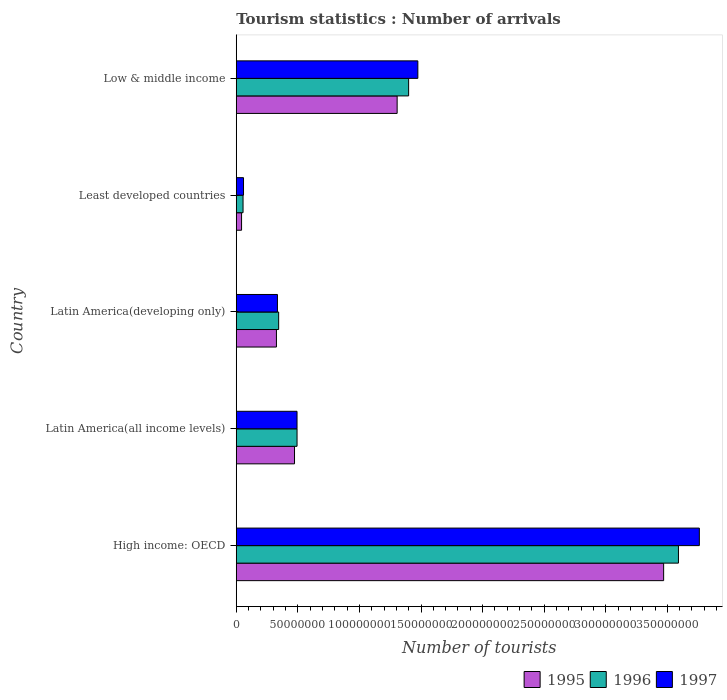How many groups of bars are there?
Offer a very short reply. 5. How many bars are there on the 2nd tick from the bottom?
Your response must be concise. 3. What is the label of the 3rd group of bars from the top?
Offer a terse response. Latin America(developing only). What is the number of tourist arrivals in 1997 in Latin America(all income levels)?
Offer a very short reply. 4.93e+07. Across all countries, what is the maximum number of tourist arrivals in 1995?
Your response must be concise. 3.47e+08. Across all countries, what is the minimum number of tourist arrivals in 1995?
Ensure brevity in your answer.  4.31e+06. In which country was the number of tourist arrivals in 1995 maximum?
Offer a very short reply. High income: OECD. In which country was the number of tourist arrivals in 1995 minimum?
Give a very brief answer. Least developed countries. What is the total number of tourist arrivals in 1996 in the graph?
Keep it short and to the point. 5.88e+08. What is the difference between the number of tourist arrivals in 1996 in Latin America(all income levels) and that in Latin America(developing only)?
Make the answer very short. 1.49e+07. What is the difference between the number of tourist arrivals in 1995 in High income: OECD and the number of tourist arrivals in 1997 in Latin America(all income levels)?
Keep it short and to the point. 2.98e+08. What is the average number of tourist arrivals in 1996 per country?
Provide a short and direct response. 1.18e+08. What is the difference between the number of tourist arrivals in 1997 and number of tourist arrivals in 1996 in High income: OECD?
Offer a very short reply. 1.70e+07. What is the ratio of the number of tourist arrivals in 1996 in Latin America(developing only) to that in Least developed countries?
Provide a short and direct response. 6.24. Is the difference between the number of tourist arrivals in 1997 in High income: OECD and Low & middle income greater than the difference between the number of tourist arrivals in 1996 in High income: OECD and Low & middle income?
Keep it short and to the point. Yes. What is the difference between the highest and the second highest number of tourist arrivals in 1997?
Offer a terse response. 2.29e+08. What is the difference between the highest and the lowest number of tourist arrivals in 1996?
Offer a terse response. 3.54e+08. Is it the case that in every country, the sum of the number of tourist arrivals in 1997 and number of tourist arrivals in 1996 is greater than the number of tourist arrivals in 1995?
Give a very brief answer. Yes. How many bars are there?
Give a very brief answer. 15. Are the values on the major ticks of X-axis written in scientific E-notation?
Offer a terse response. No. Where does the legend appear in the graph?
Your answer should be compact. Bottom right. How many legend labels are there?
Make the answer very short. 3. What is the title of the graph?
Provide a succinct answer. Tourism statistics : Number of arrivals. What is the label or title of the X-axis?
Your answer should be compact. Number of tourists. What is the Number of tourists of 1995 in High income: OECD?
Give a very brief answer. 3.47e+08. What is the Number of tourists in 1996 in High income: OECD?
Offer a very short reply. 3.59e+08. What is the Number of tourists in 1997 in High income: OECD?
Your answer should be very brief. 3.76e+08. What is the Number of tourists of 1995 in Latin America(all income levels)?
Offer a terse response. 4.73e+07. What is the Number of tourists in 1996 in Latin America(all income levels)?
Make the answer very short. 4.94e+07. What is the Number of tourists in 1997 in Latin America(all income levels)?
Offer a terse response. 4.93e+07. What is the Number of tourists of 1995 in Latin America(developing only)?
Provide a succinct answer. 3.26e+07. What is the Number of tourists of 1996 in Latin America(developing only)?
Give a very brief answer. 3.44e+07. What is the Number of tourists in 1997 in Latin America(developing only)?
Offer a very short reply. 3.34e+07. What is the Number of tourists in 1995 in Least developed countries?
Your response must be concise. 4.31e+06. What is the Number of tourists in 1996 in Least developed countries?
Your answer should be compact. 5.52e+06. What is the Number of tourists of 1997 in Least developed countries?
Your answer should be very brief. 5.89e+06. What is the Number of tourists in 1995 in Low & middle income?
Offer a terse response. 1.31e+08. What is the Number of tourists of 1996 in Low & middle income?
Your answer should be very brief. 1.40e+08. What is the Number of tourists in 1997 in Low & middle income?
Your response must be concise. 1.47e+08. Across all countries, what is the maximum Number of tourists in 1995?
Make the answer very short. 3.47e+08. Across all countries, what is the maximum Number of tourists in 1996?
Your answer should be very brief. 3.59e+08. Across all countries, what is the maximum Number of tourists of 1997?
Your response must be concise. 3.76e+08. Across all countries, what is the minimum Number of tourists in 1995?
Provide a succinct answer. 4.31e+06. Across all countries, what is the minimum Number of tourists of 1996?
Your answer should be very brief. 5.52e+06. Across all countries, what is the minimum Number of tourists of 1997?
Keep it short and to the point. 5.89e+06. What is the total Number of tourists of 1995 in the graph?
Your response must be concise. 5.62e+08. What is the total Number of tourists of 1996 in the graph?
Ensure brevity in your answer.  5.88e+08. What is the total Number of tourists of 1997 in the graph?
Offer a very short reply. 6.12e+08. What is the difference between the Number of tourists of 1995 in High income: OECD and that in Latin America(all income levels)?
Provide a succinct answer. 3.00e+08. What is the difference between the Number of tourists in 1996 in High income: OECD and that in Latin America(all income levels)?
Give a very brief answer. 3.10e+08. What is the difference between the Number of tourists of 1997 in High income: OECD and that in Latin America(all income levels)?
Keep it short and to the point. 3.27e+08. What is the difference between the Number of tourists of 1995 in High income: OECD and that in Latin America(developing only)?
Offer a very short reply. 3.14e+08. What is the difference between the Number of tourists in 1996 in High income: OECD and that in Latin America(developing only)?
Ensure brevity in your answer.  3.25e+08. What is the difference between the Number of tourists of 1997 in High income: OECD and that in Latin America(developing only)?
Keep it short and to the point. 3.43e+08. What is the difference between the Number of tourists in 1995 in High income: OECD and that in Least developed countries?
Give a very brief answer. 3.43e+08. What is the difference between the Number of tourists of 1996 in High income: OECD and that in Least developed countries?
Your response must be concise. 3.54e+08. What is the difference between the Number of tourists of 1997 in High income: OECD and that in Least developed countries?
Give a very brief answer. 3.70e+08. What is the difference between the Number of tourists in 1995 in High income: OECD and that in Low & middle income?
Make the answer very short. 2.16e+08. What is the difference between the Number of tourists of 1996 in High income: OECD and that in Low & middle income?
Provide a short and direct response. 2.19e+08. What is the difference between the Number of tourists of 1997 in High income: OECD and that in Low & middle income?
Ensure brevity in your answer.  2.29e+08. What is the difference between the Number of tourists of 1995 in Latin America(all income levels) and that in Latin America(developing only)?
Make the answer very short. 1.47e+07. What is the difference between the Number of tourists of 1996 in Latin America(all income levels) and that in Latin America(developing only)?
Give a very brief answer. 1.49e+07. What is the difference between the Number of tourists of 1997 in Latin America(all income levels) and that in Latin America(developing only)?
Your answer should be very brief. 1.59e+07. What is the difference between the Number of tourists of 1995 in Latin America(all income levels) and that in Least developed countries?
Your answer should be compact. 4.30e+07. What is the difference between the Number of tourists of 1996 in Latin America(all income levels) and that in Least developed countries?
Your answer should be compact. 4.38e+07. What is the difference between the Number of tourists of 1997 in Latin America(all income levels) and that in Least developed countries?
Provide a short and direct response. 4.34e+07. What is the difference between the Number of tourists in 1995 in Latin America(all income levels) and that in Low & middle income?
Ensure brevity in your answer.  -8.33e+07. What is the difference between the Number of tourists in 1996 in Latin America(all income levels) and that in Low & middle income?
Provide a succinct answer. -9.06e+07. What is the difference between the Number of tourists of 1997 in Latin America(all income levels) and that in Low & middle income?
Offer a very short reply. -9.81e+07. What is the difference between the Number of tourists in 1995 in Latin America(developing only) and that in Least developed countries?
Offer a terse response. 2.83e+07. What is the difference between the Number of tourists of 1996 in Latin America(developing only) and that in Least developed countries?
Provide a short and direct response. 2.89e+07. What is the difference between the Number of tourists in 1997 in Latin America(developing only) and that in Least developed countries?
Offer a very short reply. 2.76e+07. What is the difference between the Number of tourists in 1995 in Latin America(developing only) and that in Low & middle income?
Your answer should be compact. -9.80e+07. What is the difference between the Number of tourists of 1996 in Latin America(developing only) and that in Low & middle income?
Keep it short and to the point. -1.06e+08. What is the difference between the Number of tourists in 1997 in Latin America(developing only) and that in Low & middle income?
Your answer should be compact. -1.14e+08. What is the difference between the Number of tourists in 1995 in Least developed countries and that in Low & middle income?
Your answer should be very brief. -1.26e+08. What is the difference between the Number of tourists in 1996 in Least developed countries and that in Low & middle income?
Your answer should be very brief. -1.34e+08. What is the difference between the Number of tourists of 1997 in Least developed countries and that in Low & middle income?
Provide a short and direct response. -1.42e+08. What is the difference between the Number of tourists in 1995 in High income: OECD and the Number of tourists in 1996 in Latin America(all income levels)?
Offer a very short reply. 2.98e+08. What is the difference between the Number of tourists of 1995 in High income: OECD and the Number of tourists of 1997 in Latin America(all income levels)?
Provide a succinct answer. 2.98e+08. What is the difference between the Number of tourists of 1996 in High income: OECD and the Number of tourists of 1997 in Latin America(all income levels)?
Make the answer very short. 3.10e+08. What is the difference between the Number of tourists in 1995 in High income: OECD and the Number of tourists in 1996 in Latin America(developing only)?
Make the answer very short. 3.13e+08. What is the difference between the Number of tourists of 1995 in High income: OECD and the Number of tourists of 1997 in Latin America(developing only)?
Give a very brief answer. 3.14e+08. What is the difference between the Number of tourists in 1996 in High income: OECD and the Number of tourists in 1997 in Latin America(developing only)?
Your response must be concise. 3.26e+08. What is the difference between the Number of tourists of 1995 in High income: OECD and the Number of tourists of 1996 in Least developed countries?
Your answer should be very brief. 3.41e+08. What is the difference between the Number of tourists in 1995 in High income: OECD and the Number of tourists in 1997 in Least developed countries?
Make the answer very short. 3.41e+08. What is the difference between the Number of tourists of 1996 in High income: OECD and the Number of tourists of 1997 in Least developed countries?
Offer a very short reply. 3.53e+08. What is the difference between the Number of tourists in 1995 in High income: OECD and the Number of tourists in 1996 in Low & middle income?
Provide a short and direct response. 2.07e+08. What is the difference between the Number of tourists in 1995 in High income: OECD and the Number of tourists in 1997 in Low & middle income?
Give a very brief answer. 2.00e+08. What is the difference between the Number of tourists of 1996 in High income: OECD and the Number of tourists of 1997 in Low & middle income?
Your answer should be compact. 2.12e+08. What is the difference between the Number of tourists of 1995 in Latin America(all income levels) and the Number of tourists of 1996 in Latin America(developing only)?
Provide a succinct answer. 1.29e+07. What is the difference between the Number of tourists in 1995 in Latin America(all income levels) and the Number of tourists in 1997 in Latin America(developing only)?
Ensure brevity in your answer.  1.39e+07. What is the difference between the Number of tourists in 1996 in Latin America(all income levels) and the Number of tourists in 1997 in Latin America(developing only)?
Offer a terse response. 1.59e+07. What is the difference between the Number of tourists in 1995 in Latin America(all income levels) and the Number of tourists in 1996 in Least developed countries?
Provide a short and direct response. 4.18e+07. What is the difference between the Number of tourists in 1995 in Latin America(all income levels) and the Number of tourists in 1997 in Least developed countries?
Keep it short and to the point. 4.14e+07. What is the difference between the Number of tourists of 1996 in Latin America(all income levels) and the Number of tourists of 1997 in Least developed countries?
Give a very brief answer. 4.35e+07. What is the difference between the Number of tourists in 1995 in Latin America(all income levels) and the Number of tourists in 1996 in Low & middle income?
Your answer should be compact. -9.27e+07. What is the difference between the Number of tourists of 1995 in Latin America(all income levels) and the Number of tourists of 1997 in Low & middle income?
Your answer should be very brief. -1.00e+08. What is the difference between the Number of tourists in 1996 in Latin America(all income levels) and the Number of tourists in 1997 in Low & middle income?
Your answer should be very brief. -9.81e+07. What is the difference between the Number of tourists of 1995 in Latin America(developing only) and the Number of tourists of 1996 in Least developed countries?
Offer a terse response. 2.71e+07. What is the difference between the Number of tourists of 1995 in Latin America(developing only) and the Number of tourists of 1997 in Least developed countries?
Make the answer very short. 2.67e+07. What is the difference between the Number of tourists of 1996 in Latin America(developing only) and the Number of tourists of 1997 in Least developed countries?
Provide a succinct answer. 2.85e+07. What is the difference between the Number of tourists in 1995 in Latin America(developing only) and the Number of tourists in 1996 in Low & middle income?
Offer a very short reply. -1.07e+08. What is the difference between the Number of tourists in 1995 in Latin America(developing only) and the Number of tourists in 1997 in Low & middle income?
Provide a short and direct response. -1.15e+08. What is the difference between the Number of tourists of 1996 in Latin America(developing only) and the Number of tourists of 1997 in Low & middle income?
Provide a short and direct response. -1.13e+08. What is the difference between the Number of tourists of 1995 in Least developed countries and the Number of tourists of 1996 in Low & middle income?
Ensure brevity in your answer.  -1.36e+08. What is the difference between the Number of tourists of 1995 in Least developed countries and the Number of tourists of 1997 in Low & middle income?
Offer a very short reply. -1.43e+08. What is the difference between the Number of tourists of 1996 in Least developed countries and the Number of tourists of 1997 in Low & middle income?
Make the answer very short. -1.42e+08. What is the average Number of tourists of 1995 per country?
Make the answer very short. 1.12e+08. What is the average Number of tourists of 1996 per country?
Give a very brief answer. 1.18e+08. What is the average Number of tourists in 1997 per country?
Keep it short and to the point. 1.22e+08. What is the difference between the Number of tourists of 1995 and Number of tourists of 1996 in High income: OECD?
Keep it short and to the point. -1.20e+07. What is the difference between the Number of tourists of 1995 and Number of tourists of 1997 in High income: OECD?
Ensure brevity in your answer.  -2.90e+07. What is the difference between the Number of tourists of 1996 and Number of tourists of 1997 in High income: OECD?
Offer a terse response. -1.70e+07. What is the difference between the Number of tourists in 1995 and Number of tourists in 1996 in Latin America(all income levels)?
Offer a very short reply. -2.06e+06. What is the difference between the Number of tourists in 1995 and Number of tourists in 1997 in Latin America(all income levels)?
Give a very brief answer. -2.04e+06. What is the difference between the Number of tourists of 1996 and Number of tourists of 1997 in Latin America(all income levels)?
Your response must be concise. 2.15e+04. What is the difference between the Number of tourists in 1995 and Number of tourists in 1996 in Latin America(developing only)?
Your answer should be compact. -1.79e+06. What is the difference between the Number of tourists of 1995 and Number of tourists of 1997 in Latin America(developing only)?
Your response must be concise. -8.13e+05. What is the difference between the Number of tourists in 1996 and Number of tourists in 1997 in Latin America(developing only)?
Provide a succinct answer. 9.79e+05. What is the difference between the Number of tourists of 1995 and Number of tourists of 1996 in Least developed countries?
Offer a terse response. -1.21e+06. What is the difference between the Number of tourists of 1995 and Number of tourists of 1997 in Least developed countries?
Your response must be concise. -1.58e+06. What is the difference between the Number of tourists in 1996 and Number of tourists in 1997 in Least developed countries?
Your answer should be very brief. -3.73e+05. What is the difference between the Number of tourists of 1995 and Number of tourists of 1996 in Low & middle income?
Offer a very short reply. -9.32e+06. What is the difference between the Number of tourists of 1995 and Number of tourists of 1997 in Low & middle income?
Give a very brief answer. -1.68e+07. What is the difference between the Number of tourists in 1996 and Number of tourists in 1997 in Low & middle income?
Your response must be concise. -7.48e+06. What is the ratio of the Number of tourists in 1995 in High income: OECD to that in Latin America(all income levels)?
Provide a short and direct response. 7.34. What is the ratio of the Number of tourists in 1996 in High income: OECD to that in Latin America(all income levels)?
Your answer should be compact. 7.27. What is the ratio of the Number of tourists of 1997 in High income: OECD to that in Latin America(all income levels)?
Your answer should be compact. 7.62. What is the ratio of the Number of tourists in 1995 in High income: OECD to that in Latin America(developing only)?
Ensure brevity in your answer.  10.63. What is the ratio of the Number of tourists in 1996 in High income: OECD to that in Latin America(developing only)?
Offer a terse response. 10.43. What is the ratio of the Number of tourists in 1997 in High income: OECD to that in Latin America(developing only)?
Give a very brief answer. 11.24. What is the ratio of the Number of tourists in 1995 in High income: OECD to that in Least developed countries?
Your response must be concise. 80.45. What is the ratio of the Number of tourists of 1996 in High income: OECD to that in Least developed countries?
Your answer should be very brief. 65.04. What is the ratio of the Number of tourists of 1997 in High income: OECD to that in Least developed countries?
Give a very brief answer. 63.8. What is the ratio of the Number of tourists of 1995 in High income: OECD to that in Low & middle income?
Ensure brevity in your answer.  2.66. What is the ratio of the Number of tourists of 1996 in High income: OECD to that in Low & middle income?
Your answer should be very brief. 2.57. What is the ratio of the Number of tourists of 1997 in High income: OECD to that in Low & middle income?
Keep it short and to the point. 2.55. What is the ratio of the Number of tourists in 1995 in Latin America(all income levels) to that in Latin America(developing only)?
Your answer should be very brief. 1.45. What is the ratio of the Number of tourists of 1996 in Latin America(all income levels) to that in Latin America(developing only)?
Provide a succinct answer. 1.43. What is the ratio of the Number of tourists of 1997 in Latin America(all income levels) to that in Latin America(developing only)?
Give a very brief answer. 1.48. What is the ratio of the Number of tourists in 1995 in Latin America(all income levels) to that in Least developed countries?
Give a very brief answer. 10.97. What is the ratio of the Number of tourists of 1996 in Latin America(all income levels) to that in Least developed countries?
Offer a terse response. 8.94. What is the ratio of the Number of tourists in 1997 in Latin America(all income levels) to that in Least developed countries?
Provide a succinct answer. 8.37. What is the ratio of the Number of tourists in 1995 in Latin America(all income levels) to that in Low & middle income?
Provide a succinct answer. 0.36. What is the ratio of the Number of tourists of 1996 in Latin America(all income levels) to that in Low & middle income?
Your response must be concise. 0.35. What is the ratio of the Number of tourists in 1997 in Latin America(all income levels) to that in Low & middle income?
Make the answer very short. 0.33. What is the ratio of the Number of tourists in 1995 in Latin America(developing only) to that in Least developed countries?
Make the answer very short. 7.56. What is the ratio of the Number of tourists of 1996 in Latin America(developing only) to that in Least developed countries?
Ensure brevity in your answer.  6.24. What is the ratio of the Number of tourists of 1997 in Latin America(developing only) to that in Least developed countries?
Offer a very short reply. 5.67. What is the ratio of the Number of tourists in 1995 in Latin America(developing only) to that in Low & middle income?
Give a very brief answer. 0.25. What is the ratio of the Number of tourists of 1996 in Latin America(developing only) to that in Low & middle income?
Provide a succinct answer. 0.25. What is the ratio of the Number of tourists of 1997 in Latin America(developing only) to that in Low & middle income?
Your answer should be compact. 0.23. What is the ratio of the Number of tourists of 1995 in Least developed countries to that in Low & middle income?
Offer a very short reply. 0.03. What is the ratio of the Number of tourists in 1996 in Least developed countries to that in Low & middle income?
Provide a succinct answer. 0.04. What is the difference between the highest and the second highest Number of tourists in 1995?
Offer a terse response. 2.16e+08. What is the difference between the highest and the second highest Number of tourists in 1996?
Give a very brief answer. 2.19e+08. What is the difference between the highest and the second highest Number of tourists of 1997?
Offer a terse response. 2.29e+08. What is the difference between the highest and the lowest Number of tourists in 1995?
Provide a short and direct response. 3.43e+08. What is the difference between the highest and the lowest Number of tourists of 1996?
Keep it short and to the point. 3.54e+08. What is the difference between the highest and the lowest Number of tourists in 1997?
Keep it short and to the point. 3.70e+08. 